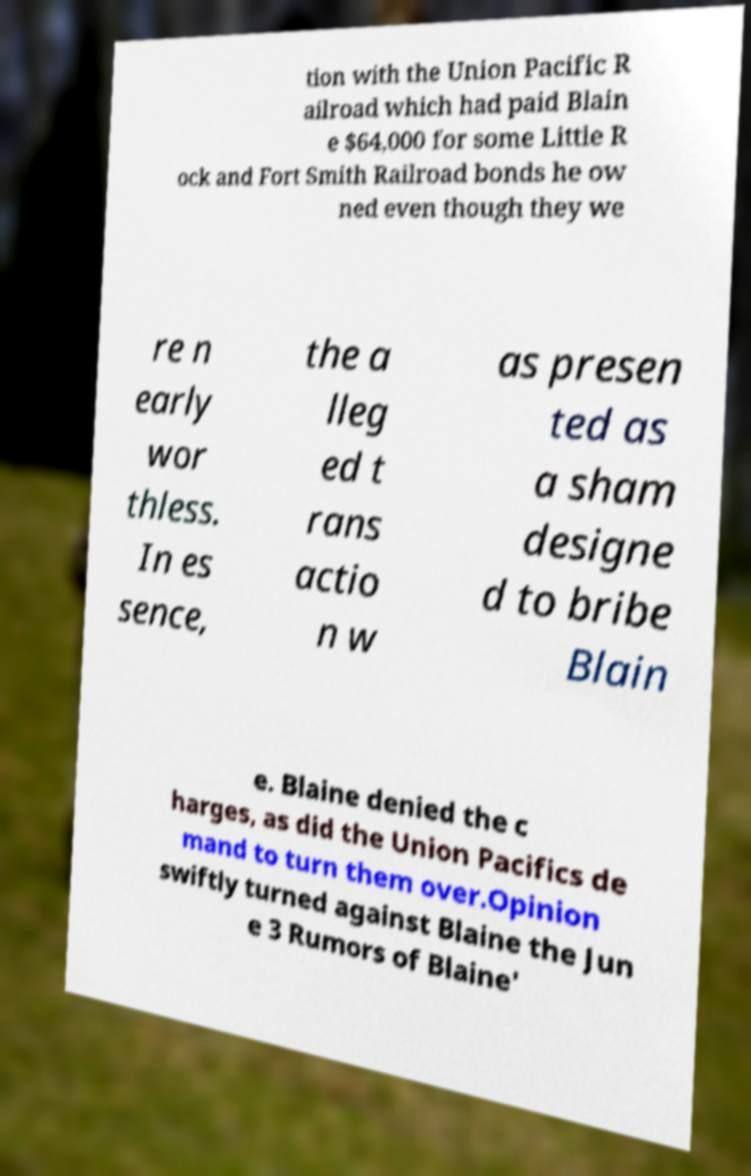Please read and relay the text visible in this image. What does it say? tion with the Union Pacific R ailroad which had paid Blain e $64,000 for some Little R ock and Fort Smith Railroad bonds he ow ned even though they we re n early wor thless. In es sence, the a lleg ed t rans actio n w as presen ted as a sham designe d to bribe Blain e. Blaine denied the c harges, as did the Union Pacifics de mand to turn them over.Opinion swiftly turned against Blaine the Jun e 3 Rumors of Blaine' 